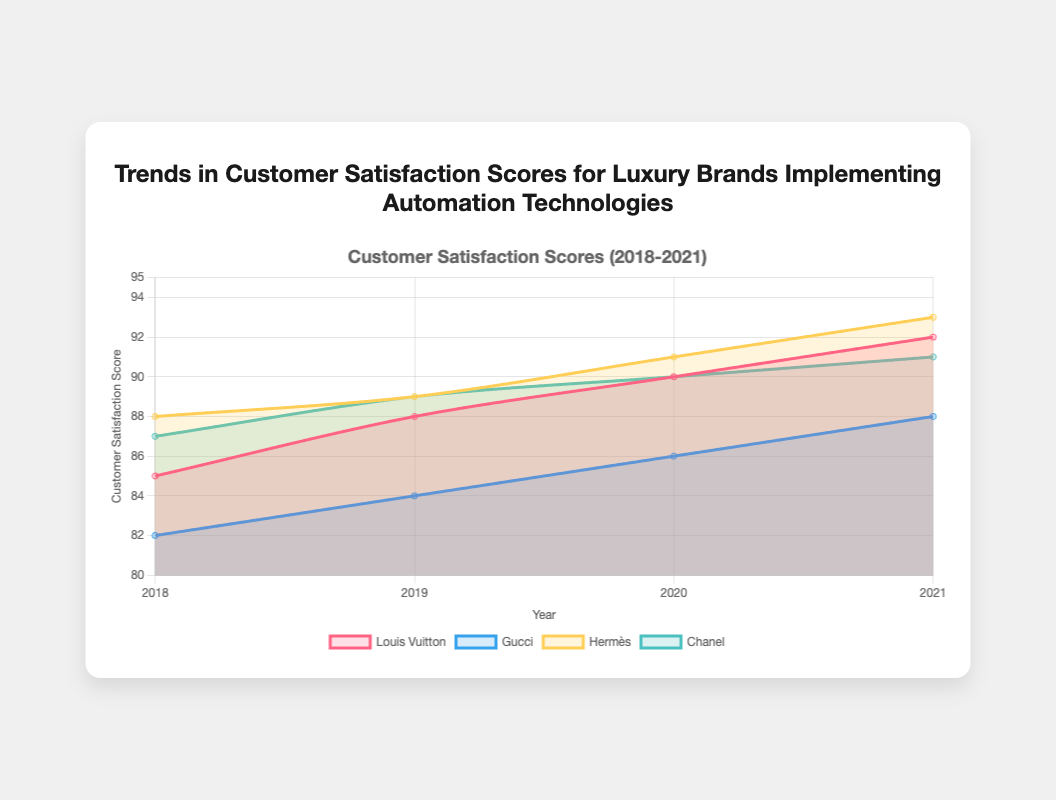What is the title of the chart? The title of the chart is prominently displayed at the top of the figure. It reads "Trends in Customer Satisfaction Scores for Luxury Brands Implementing Automation Technologies".
Answer: Trends in Customer Satisfaction Scores for Luxury Brands Implementing Automation Technologies How many years of data are displayed in the chart? The x-axis of the chart lists the years for which data is available, which are 2018, 2019, 2020, and 2021.
Answer: 4 years Which luxury brand had the highest customer satisfaction score in 2021? By identifying and comparing the data points for 2021 across all brands, Hermès has the highest score at 93.
Answer: Hermès What is the difference in satisfaction scores between Gucci and Louis Vuitton in 2019? For 2019, Louis Vuitton's score is 88 and Gucci's score is 84. The difference is 88 - 84.
Answer: 4 Which brand showed the biggest improvement in customer satisfaction from 2018 to 2021? To determine the biggest improvement, we need to calculate the difference between the 2021 and 2018 scores for each brand. Louis Vuitton improved by 92 - 85 = 7, Gucci by 88 - 82 = 6, Hermès by 93 - 88 = 5, and Chanel by 91 - 87 = 4. Louis Vuitton shows the largest improvement.
Answer: Louis Vuitton What color represents Hermès in the chart? By examining the legend for the colors associated with each brand, Hermès is represented by a light yellow color in the chart.
Answer: Light yellow What's the average customer satisfaction score of Chanel over the four years? To find the average, add Chanel's scores for each year: 87 (2018) + 89 (2019) + 90 (2020) + 91 (2021) = 357. Then divide by 4.
Answer: 89.25 Which brand's customer satisfaction score was equal to 90 in any of the years? By scanning the data points, both Louis Vuitton and Chanel have a score of 90 in 2020.
Answer: Louis Vuitton, Chanel What general trend can be observed across all brands from 2018 to 2021? Reviewing the chart shows that the customer satisfaction scores for all brands steadily increased from 2018 to 2021.
Answer: Increasing trend By how much did the average customer satisfaction score improve for all brands from 2018 to 2021? First, find the average score for all brands in 2018 and 2021. For 2018: (85 (LV) + 82 (G) + 88 (H) + 87 (C)) / 4 = 85.5. For 2021: (92 (LV) + 88 (G) + 93 (H) + 91 (C)) / 4 = 91. The improvement is 91 - 85.5.
Answer: 5.5 Which brands had the same customer satisfaction score in any year, and what was that score? Scan data points to find any common scores. In 2020, Louis Vuitton and Chanel both had a customer satisfaction score of 90.
Answer: Louis Vuitton, Chanel, 90 